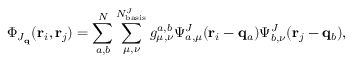<formula> <loc_0><loc_0><loc_500><loc_500>\Phi _ { J _ { q } } ( r _ { i } , r _ { j } ) = \sum _ { a , b } ^ { N } \sum _ { \mu , \nu } ^ { N _ { b a s i s } ^ { J } } g _ { \mu , \nu } ^ { a , b } \Psi _ { a , \mu } ^ { J } ( r _ { i } - q _ { a } ) \Psi _ { b , \nu } ^ { J } ( r _ { j } - q _ { b } ) ,</formula> 